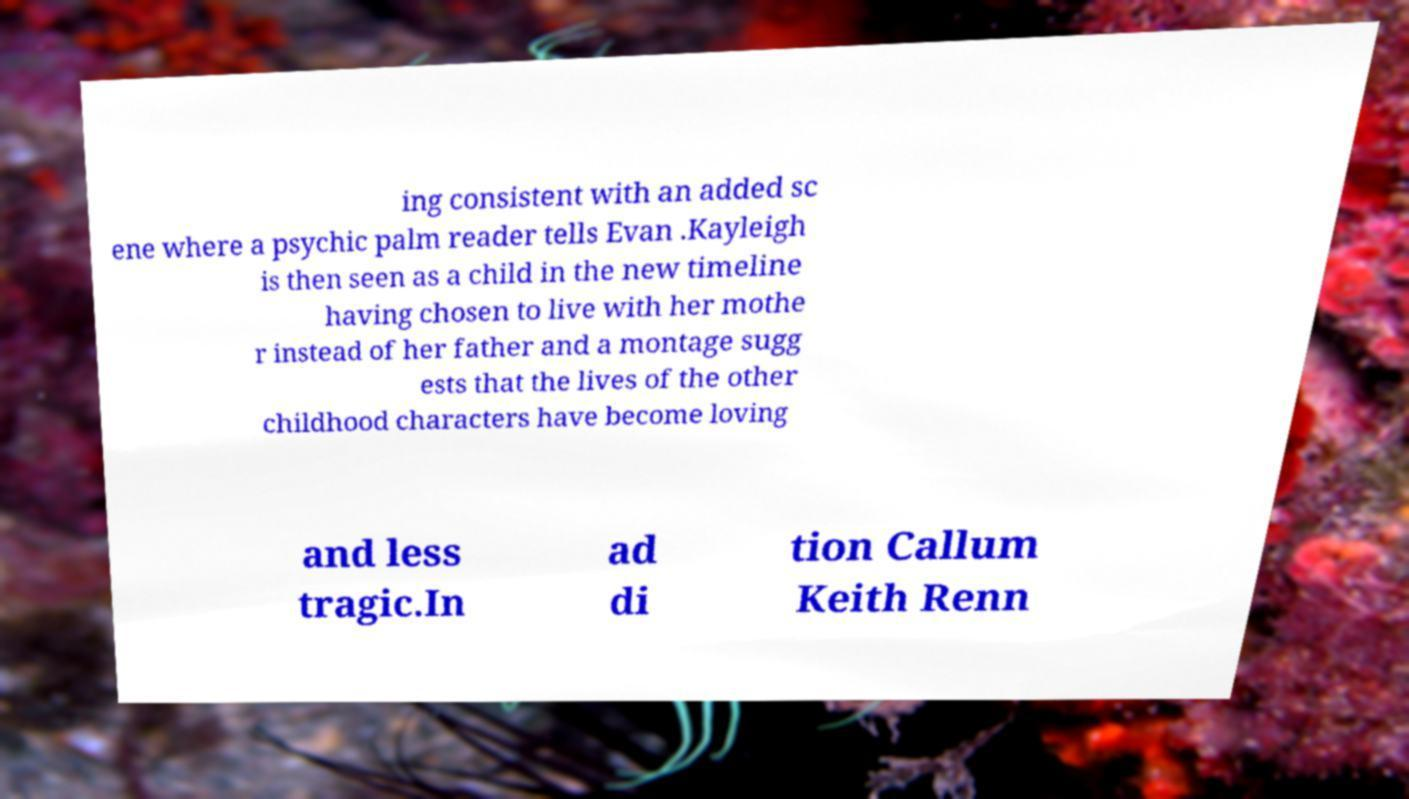Can you read and provide the text displayed in the image?This photo seems to have some interesting text. Can you extract and type it out for me? ing consistent with an added sc ene where a psychic palm reader tells Evan .Kayleigh is then seen as a child in the new timeline having chosen to live with her mothe r instead of her father and a montage sugg ests that the lives of the other childhood characters have become loving and less tragic.In ad di tion Callum Keith Renn 